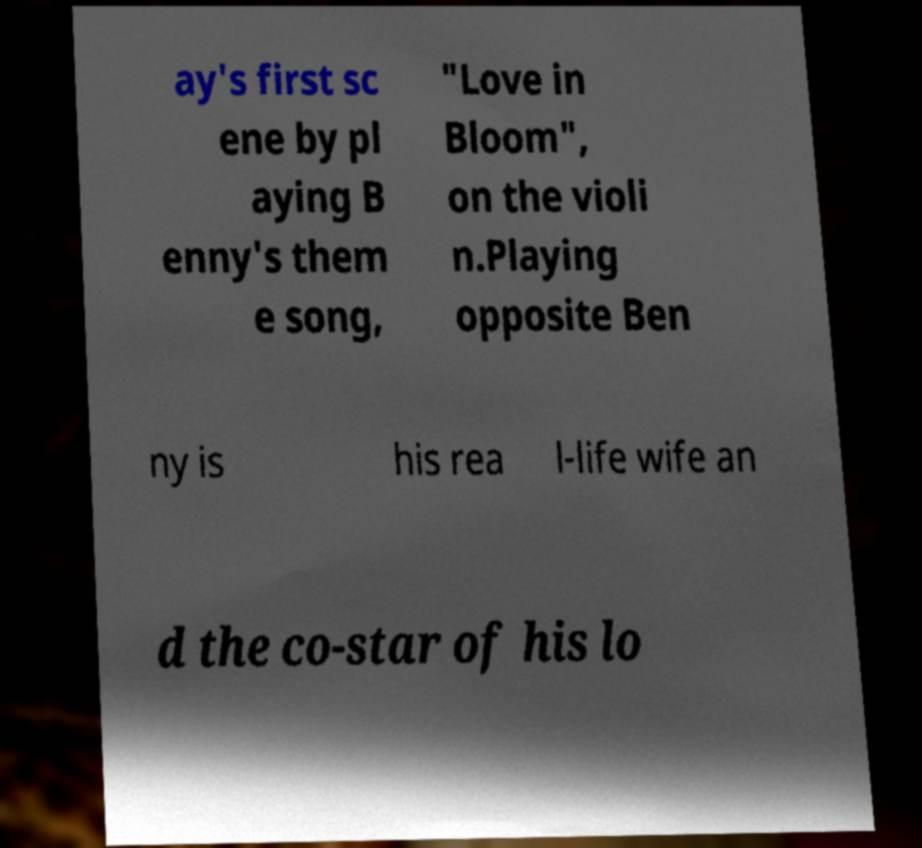For documentation purposes, I need the text within this image transcribed. Could you provide that? ay's first sc ene by pl aying B enny's them e song, "Love in Bloom", on the violi n.Playing opposite Ben ny is his rea l-life wife an d the co-star of his lo 